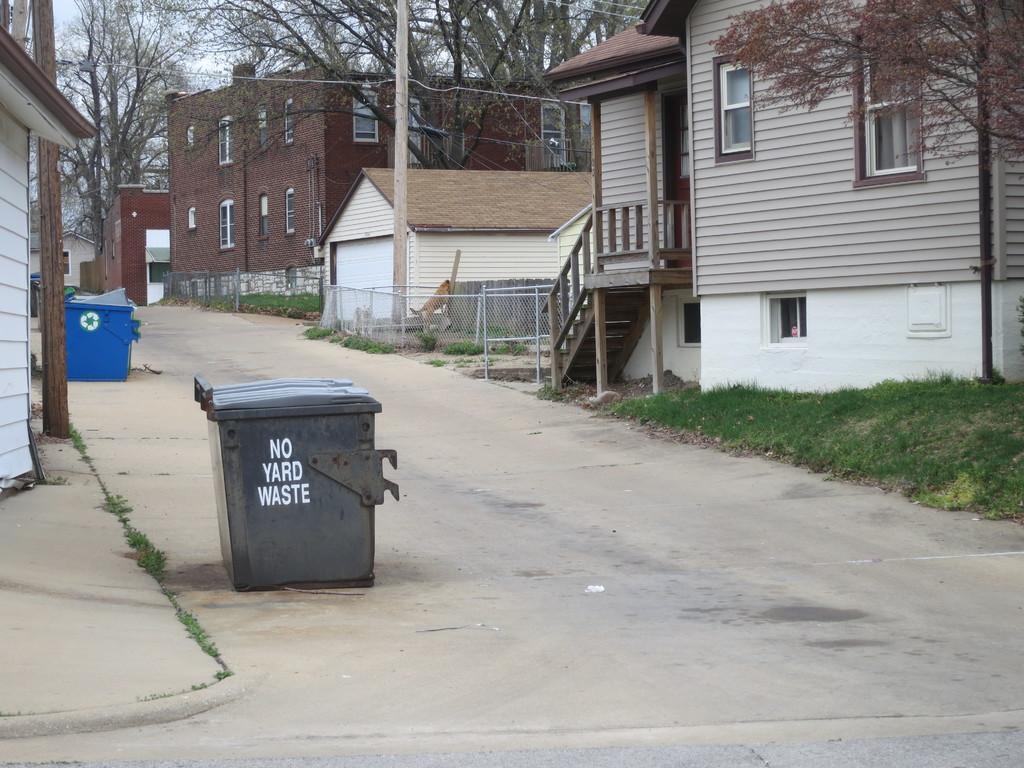Please provide a concise description of this image. At the bottom, we see the road. In the middle, we see a garbage bin in grey color. On the left side, we see a building in white color. Beside that, we see the poles and a garbage bin in blue color. On the right side, we see the grass, tree and a building, We see the fence, staircase and the stair railing. We even see a dog and a pole. There are trees and the buildings in the background. At the top, we see the sky. 